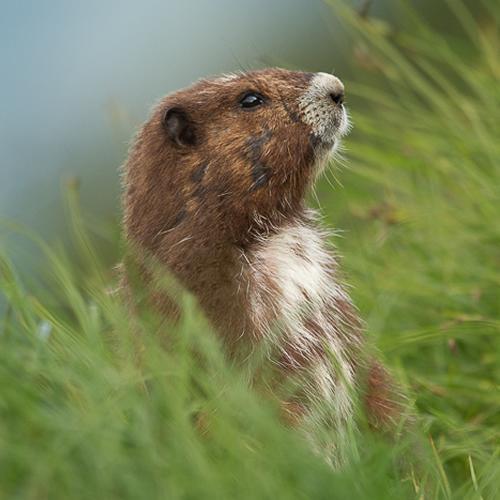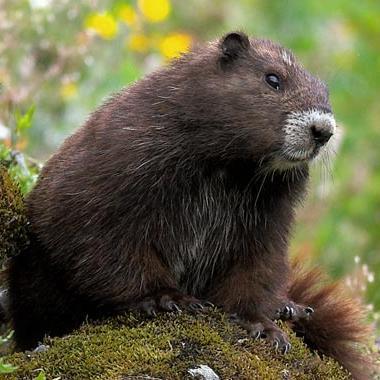The first image is the image on the left, the second image is the image on the right. For the images shown, is this caption "the animal is standing up on the left pic" true? Answer yes or no. Yes. The first image is the image on the left, the second image is the image on the right. Considering the images on both sides, is "One of the gophers has a long white underbelly and the gopher that is sitting on a rock or mossy log, does not." valid? Answer yes or no. Yes. 